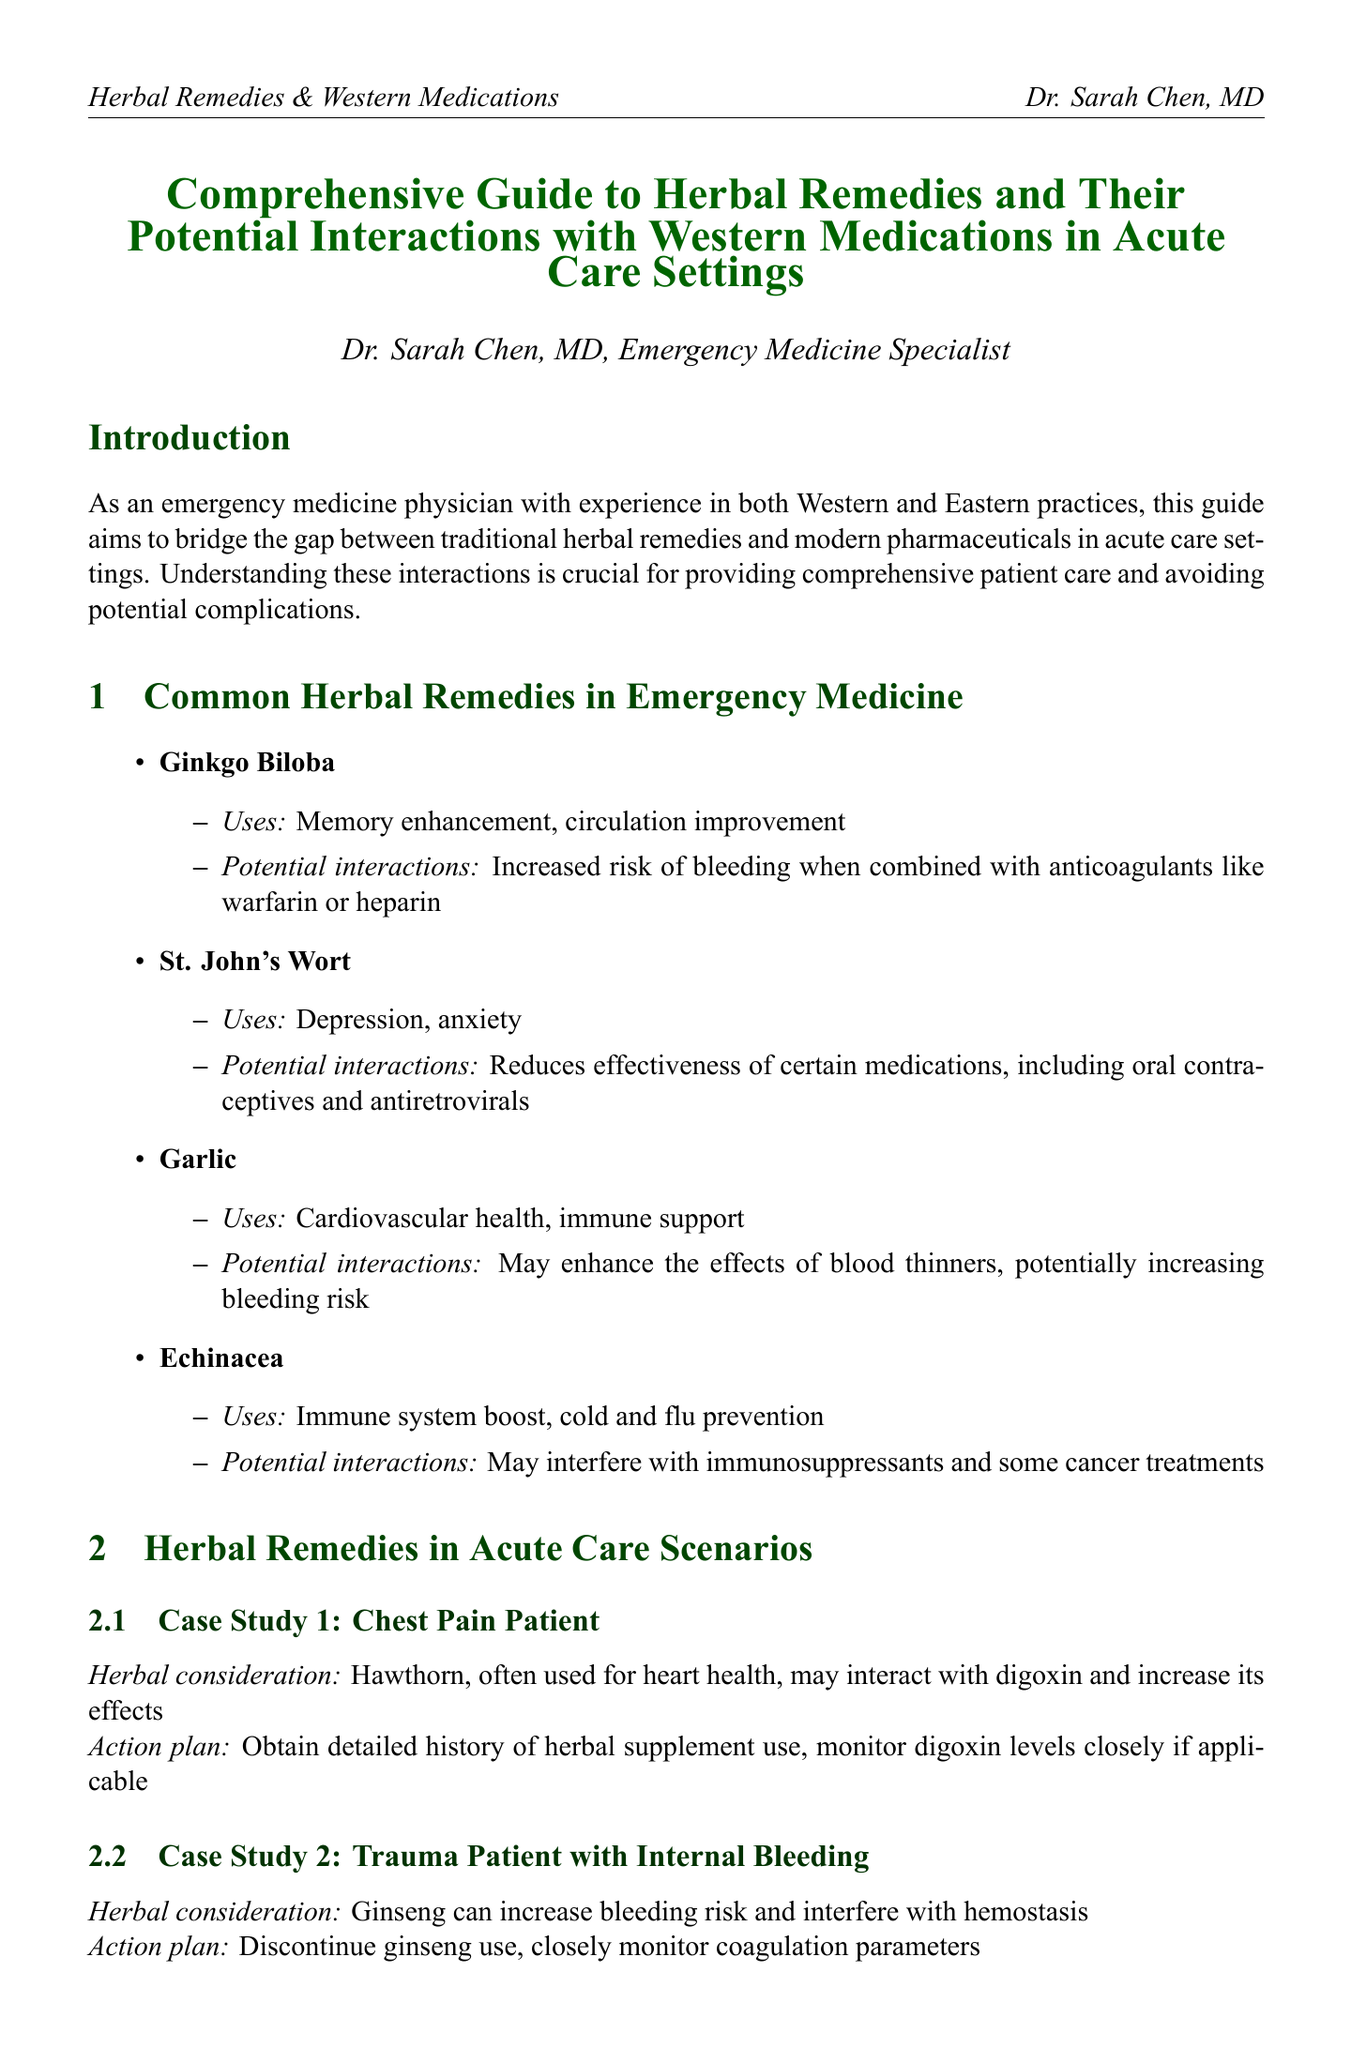What is the title of the manual? The title of the manual is stated in the document's heading.
Answer: Comprehensive Guide to Herbal Remedies and Their Potential Interactions with Western Medications in Acute Care Settings Who is the author? The author is introduced in the document's introduction section.
Answer: Dr. Sarah Chen, MD, Emergency Medicine Specialist What does Ginkgo Biloba enhance? The uses of Ginkgo Biloba are listed under the common herbal remedies section.
Answer: Memory enhancement Which herbal remedy may interfere with immunosuppressants? The potential interactions of specific herbs are discussed in the common herbal remedies section.
Answer: Echinacea What is the action plan for a chest pain patient? The action plan for the case study involving a chest pain patient is detailed in the acute care scenarios section.
Answer: Obtain detailed history of herbal supplement use, monitor digoxin levels closely if applicable How does St. John's Wort affect oral contraceptives? The document notes specific interactions of St. John's Wort in the common herbal remedies section.
Answer: Reduces effectiveness What should be developed for emergency department triage? Strategies for integrating Eastern and Western approaches are proposed in the document.
Answer: A standardized herbal supplement history intake form How can herbal remedies affect laboratory test results? The implications of herbal remedies on lab tests are discussed in the laboratory considerations section.
Answer: Can cause false elevations in thyroid function tests What is a key point of patient education? Important aspects of patient education regarding herbal remedies are listed in that section.
Answer: Encourage patients to disclose all herbal supplement use 